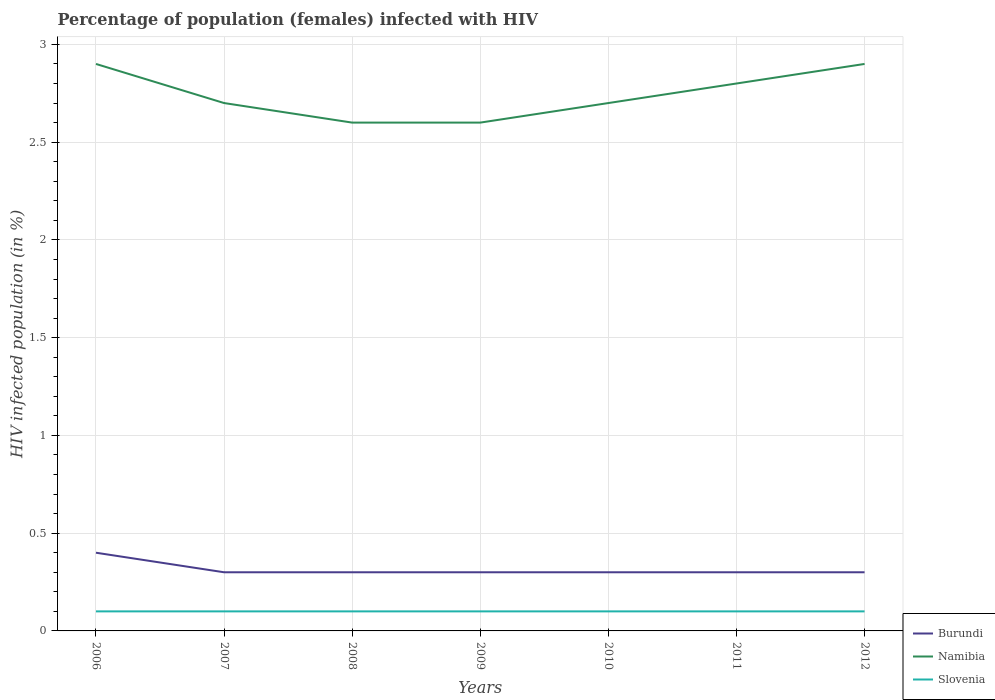Does the line corresponding to Namibia intersect with the line corresponding to Burundi?
Provide a short and direct response. No. Is the number of lines equal to the number of legend labels?
Offer a very short reply. Yes. Across all years, what is the maximum percentage of HIV infected female population in Slovenia?
Provide a short and direct response. 0.1. In which year was the percentage of HIV infected female population in Burundi maximum?
Your response must be concise. 2007. What is the total percentage of HIV infected female population in Burundi in the graph?
Your answer should be compact. 0.1. What is the difference between the highest and the second highest percentage of HIV infected female population in Burundi?
Ensure brevity in your answer.  0.1. How many lines are there?
Your answer should be compact. 3. How many years are there in the graph?
Provide a succinct answer. 7. What is the difference between two consecutive major ticks on the Y-axis?
Your answer should be compact. 0.5. Are the values on the major ticks of Y-axis written in scientific E-notation?
Keep it short and to the point. No. Where does the legend appear in the graph?
Your answer should be compact. Bottom right. How many legend labels are there?
Give a very brief answer. 3. What is the title of the graph?
Keep it short and to the point. Percentage of population (females) infected with HIV. What is the label or title of the X-axis?
Make the answer very short. Years. What is the label or title of the Y-axis?
Ensure brevity in your answer.  HIV infected population (in %). What is the HIV infected population (in %) of Namibia in 2007?
Ensure brevity in your answer.  2.7. What is the HIV infected population (in %) in Burundi in 2009?
Provide a short and direct response. 0.3. What is the HIV infected population (in %) in Namibia in 2009?
Your answer should be very brief. 2.6. What is the HIV infected population (in %) in Namibia in 2011?
Offer a terse response. 2.8. What is the HIV infected population (in %) in Burundi in 2012?
Your answer should be compact. 0.3. Across all years, what is the minimum HIV infected population (in %) in Burundi?
Your response must be concise. 0.3. Across all years, what is the minimum HIV infected population (in %) in Namibia?
Provide a short and direct response. 2.6. Across all years, what is the minimum HIV infected population (in %) in Slovenia?
Your answer should be very brief. 0.1. What is the total HIV infected population (in %) in Burundi in the graph?
Offer a terse response. 2.2. What is the total HIV infected population (in %) of Namibia in the graph?
Make the answer very short. 19.2. What is the difference between the HIV infected population (in %) in Namibia in 2006 and that in 2007?
Provide a succinct answer. 0.2. What is the difference between the HIV infected population (in %) of Slovenia in 2006 and that in 2007?
Keep it short and to the point. 0. What is the difference between the HIV infected population (in %) of Burundi in 2006 and that in 2008?
Keep it short and to the point. 0.1. What is the difference between the HIV infected population (in %) of Slovenia in 2006 and that in 2008?
Your response must be concise. 0. What is the difference between the HIV infected population (in %) in Burundi in 2006 and that in 2009?
Keep it short and to the point. 0.1. What is the difference between the HIV infected population (in %) of Burundi in 2006 and that in 2010?
Keep it short and to the point. 0.1. What is the difference between the HIV infected population (in %) of Slovenia in 2006 and that in 2010?
Give a very brief answer. 0. What is the difference between the HIV infected population (in %) of Namibia in 2006 and that in 2011?
Offer a terse response. 0.1. What is the difference between the HIV infected population (in %) in Namibia in 2006 and that in 2012?
Your response must be concise. 0. What is the difference between the HIV infected population (in %) of Namibia in 2007 and that in 2009?
Offer a terse response. 0.1. What is the difference between the HIV infected population (in %) of Namibia in 2007 and that in 2010?
Provide a succinct answer. 0. What is the difference between the HIV infected population (in %) of Slovenia in 2007 and that in 2010?
Your answer should be very brief. 0. What is the difference between the HIV infected population (in %) in Namibia in 2007 and that in 2011?
Your answer should be very brief. -0.1. What is the difference between the HIV infected population (in %) of Slovenia in 2007 and that in 2011?
Provide a succinct answer. 0. What is the difference between the HIV infected population (in %) in Burundi in 2007 and that in 2012?
Keep it short and to the point. 0. What is the difference between the HIV infected population (in %) of Namibia in 2007 and that in 2012?
Your answer should be compact. -0.2. What is the difference between the HIV infected population (in %) in Burundi in 2008 and that in 2009?
Your answer should be compact. 0. What is the difference between the HIV infected population (in %) of Slovenia in 2008 and that in 2009?
Provide a succinct answer. 0. What is the difference between the HIV infected population (in %) in Burundi in 2008 and that in 2010?
Provide a short and direct response. 0. What is the difference between the HIV infected population (in %) of Burundi in 2008 and that in 2011?
Keep it short and to the point. 0. What is the difference between the HIV infected population (in %) of Namibia in 2008 and that in 2011?
Offer a very short reply. -0.2. What is the difference between the HIV infected population (in %) of Slovenia in 2008 and that in 2012?
Offer a very short reply. 0. What is the difference between the HIV infected population (in %) in Burundi in 2009 and that in 2010?
Ensure brevity in your answer.  0. What is the difference between the HIV infected population (in %) of Slovenia in 2009 and that in 2010?
Your answer should be compact. 0. What is the difference between the HIV infected population (in %) of Burundi in 2009 and that in 2011?
Your answer should be very brief. 0. What is the difference between the HIV infected population (in %) in Namibia in 2009 and that in 2011?
Offer a terse response. -0.2. What is the difference between the HIV infected population (in %) in Burundi in 2010 and that in 2011?
Your answer should be compact. 0. What is the difference between the HIV infected population (in %) in Namibia in 2010 and that in 2011?
Your answer should be compact. -0.1. What is the difference between the HIV infected population (in %) in Slovenia in 2010 and that in 2011?
Ensure brevity in your answer.  0. What is the difference between the HIV infected population (in %) of Burundi in 2010 and that in 2012?
Provide a short and direct response. 0. What is the difference between the HIV infected population (in %) in Burundi in 2011 and that in 2012?
Your response must be concise. 0. What is the difference between the HIV infected population (in %) in Namibia in 2011 and that in 2012?
Your answer should be very brief. -0.1. What is the difference between the HIV infected population (in %) of Slovenia in 2011 and that in 2012?
Your answer should be compact. 0. What is the difference between the HIV infected population (in %) of Burundi in 2006 and the HIV infected population (in %) of Namibia in 2007?
Make the answer very short. -2.3. What is the difference between the HIV infected population (in %) of Burundi in 2006 and the HIV infected population (in %) of Slovenia in 2007?
Keep it short and to the point. 0.3. What is the difference between the HIV infected population (in %) in Burundi in 2006 and the HIV infected population (in %) in Namibia in 2008?
Provide a succinct answer. -2.2. What is the difference between the HIV infected population (in %) in Burundi in 2006 and the HIV infected population (in %) in Namibia in 2009?
Keep it short and to the point. -2.2. What is the difference between the HIV infected population (in %) in Burundi in 2006 and the HIV infected population (in %) in Slovenia in 2010?
Your response must be concise. 0.3. What is the difference between the HIV infected population (in %) of Namibia in 2006 and the HIV infected population (in %) of Slovenia in 2010?
Give a very brief answer. 2.8. What is the difference between the HIV infected population (in %) in Burundi in 2006 and the HIV infected population (in %) in Slovenia in 2012?
Offer a terse response. 0.3. What is the difference between the HIV infected population (in %) of Burundi in 2007 and the HIV infected population (in %) of Slovenia in 2008?
Give a very brief answer. 0.2. What is the difference between the HIV infected population (in %) in Namibia in 2007 and the HIV infected population (in %) in Slovenia in 2008?
Your response must be concise. 2.6. What is the difference between the HIV infected population (in %) of Burundi in 2007 and the HIV infected population (in %) of Namibia in 2009?
Provide a short and direct response. -2.3. What is the difference between the HIV infected population (in %) in Burundi in 2007 and the HIV infected population (in %) in Slovenia in 2009?
Provide a succinct answer. 0.2. What is the difference between the HIV infected population (in %) of Namibia in 2007 and the HIV infected population (in %) of Slovenia in 2009?
Give a very brief answer. 2.6. What is the difference between the HIV infected population (in %) in Namibia in 2007 and the HIV infected population (in %) in Slovenia in 2010?
Offer a very short reply. 2.6. What is the difference between the HIV infected population (in %) of Burundi in 2007 and the HIV infected population (in %) of Slovenia in 2011?
Your answer should be compact. 0.2. What is the difference between the HIV infected population (in %) of Namibia in 2007 and the HIV infected population (in %) of Slovenia in 2011?
Give a very brief answer. 2.6. What is the difference between the HIV infected population (in %) of Burundi in 2007 and the HIV infected population (in %) of Namibia in 2012?
Your answer should be very brief. -2.6. What is the difference between the HIV infected population (in %) of Namibia in 2007 and the HIV infected population (in %) of Slovenia in 2012?
Make the answer very short. 2.6. What is the difference between the HIV infected population (in %) in Burundi in 2008 and the HIV infected population (in %) in Slovenia in 2009?
Make the answer very short. 0.2. What is the difference between the HIV infected population (in %) in Namibia in 2008 and the HIV infected population (in %) in Slovenia in 2009?
Offer a terse response. 2.5. What is the difference between the HIV infected population (in %) of Burundi in 2008 and the HIV infected population (in %) of Slovenia in 2010?
Offer a terse response. 0.2. What is the difference between the HIV infected population (in %) in Burundi in 2008 and the HIV infected population (in %) in Slovenia in 2011?
Offer a very short reply. 0.2. What is the difference between the HIV infected population (in %) of Namibia in 2008 and the HIV infected population (in %) of Slovenia in 2011?
Ensure brevity in your answer.  2.5. What is the difference between the HIV infected population (in %) of Burundi in 2008 and the HIV infected population (in %) of Slovenia in 2012?
Offer a very short reply. 0.2. What is the difference between the HIV infected population (in %) in Namibia in 2008 and the HIV infected population (in %) in Slovenia in 2012?
Ensure brevity in your answer.  2.5. What is the difference between the HIV infected population (in %) in Burundi in 2009 and the HIV infected population (in %) in Namibia in 2010?
Make the answer very short. -2.4. What is the difference between the HIV infected population (in %) in Burundi in 2009 and the HIV infected population (in %) in Slovenia in 2010?
Your answer should be compact. 0.2. What is the difference between the HIV infected population (in %) of Burundi in 2009 and the HIV infected population (in %) of Slovenia in 2011?
Your response must be concise. 0.2. What is the difference between the HIV infected population (in %) in Namibia in 2009 and the HIV infected population (in %) in Slovenia in 2012?
Your answer should be very brief. 2.5. What is the difference between the HIV infected population (in %) of Burundi in 2010 and the HIV infected population (in %) of Slovenia in 2011?
Provide a succinct answer. 0.2. What is the difference between the HIV infected population (in %) of Namibia in 2010 and the HIV infected population (in %) of Slovenia in 2011?
Provide a succinct answer. 2.6. What is the difference between the HIV infected population (in %) of Burundi in 2010 and the HIV infected population (in %) of Namibia in 2012?
Offer a terse response. -2.6. What is the difference between the HIV infected population (in %) of Burundi in 2010 and the HIV infected population (in %) of Slovenia in 2012?
Your response must be concise. 0.2. What is the average HIV infected population (in %) in Burundi per year?
Provide a succinct answer. 0.31. What is the average HIV infected population (in %) in Namibia per year?
Offer a terse response. 2.74. What is the average HIV infected population (in %) of Slovenia per year?
Keep it short and to the point. 0.1. In the year 2006, what is the difference between the HIV infected population (in %) of Burundi and HIV infected population (in %) of Slovenia?
Your answer should be very brief. 0.3. In the year 2007, what is the difference between the HIV infected population (in %) of Namibia and HIV infected population (in %) of Slovenia?
Your answer should be very brief. 2.6. In the year 2009, what is the difference between the HIV infected population (in %) of Burundi and HIV infected population (in %) of Slovenia?
Your response must be concise. 0.2. In the year 2009, what is the difference between the HIV infected population (in %) in Namibia and HIV infected population (in %) in Slovenia?
Keep it short and to the point. 2.5. In the year 2010, what is the difference between the HIV infected population (in %) in Burundi and HIV infected population (in %) in Namibia?
Give a very brief answer. -2.4. In the year 2010, what is the difference between the HIV infected population (in %) of Namibia and HIV infected population (in %) of Slovenia?
Give a very brief answer. 2.6. In the year 2011, what is the difference between the HIV infected population (in %) in Burundi and HIV infected population (in %) in Namibia?
Make the answer very short. -2.5. In the year 2012, what is the difference between the HIV infected population (in %) of Burundi and HIV infected population (in %) of Namibia?
Offer a terse response. -2.6. In the year 2012, what is the difference between the HIV infected population (in %) in Burundi and HIV infected population (in %) in Slovenia?
Make the answer very short. 0.2. What is the ratio of the HIV infected population (in %) of Burundi in 2006 to that in 2007?
Offer a very short reply. 1.33. What is the ratio of the HIV infected population (in %) in Namibia in 2006 to that in 2007?
Your answer should be compact. 1.07. What is the ratio of the HIV infected population (in %) of Burundi in 2006 to that in 2008?
Your answer should be compact. 1.33. What is the ratio of the HIV infected population (in %) of Namibia in 2006 to that in 2008?
Offer a terse response. 1.12. What is the ratio of the HIV infected population (in %) of Namibia in 2006 to that in 2009?
Provide a short and direct response. 1.12. What is the ratio of the HIV infected population (in %) of Namibia in 2006 to that in 2010?
Ensure brevity in your answer.  1.07. What is the ratio of the HIV infected population (in %) of Namibia in 2006 to that in 2011?
Keep it short and to the point. 1.04. What is the ratio of the HIV infected population (in %) in Slovenia in 2006 to that in 2011?
Your answer should be very brief. 1. What is the ratio of the HIV infected population (in %) in Namibia in 2006 to that in 2012?
Offer a very short reply. 1. What is the ratio of the HIV infected population (in %) in Burundi in 2007 to that in 2009?
Your answer should be compact. 1. What is the ratio of the HIV infected population (in %) in Namibia in 2007 to that in 2009?
Provide a succinct answer. 1.04. What is the ratio of the HIV infected population (in %) of Burundi in 2007 to that in 2010?
Provide a succinct answer. 1. What is the ratio of the HIV infected population (in %) of Namibia in 2007 to that in 2010?
Your answer should be compact. 1. What is the ratio of the HIV infected population (in %) of Burundi in 2007 to that in 2012?
Your answer should be compact. 1. What is the ratio of the HIV infected population (in %) in Namibia in 2007 to that in 2012?
Offer a very short reply. 0.93. What is the ratio of the HIV infected population (in %) of Slovenia in 2007 to that in 2012?
Ensure brevity in your answer.  1. What is the ratio of the HIV infected population (in %) of Burundi in 2008 to that in 2010?
Your response must be concise. 1. What is the ratio of the HIV infected population (in %) in Slovenia in 2008 to that in 2010?
Provide a succinct answer. 1. What is the ratio of the HIV infected population (in %) of Burundi in 2008 to that in 2011?
Your answer should be compact. 1. What is the ratio of the HIV infected population (in %) of Namibia in 2008 to that in 2011?
Provide a short and direct response. 0.93. What is the ratio of the HIV infected population (in %) in Slovenia in 2008 to that in 2011?
Your answer should be very brief. 1. What is the ratio of the HIV infected population (in %) in Burundi in 2008 to that in 2012?
Give a very brief answer. 1. What is the ratio of the HIV infected population (in %) in Namibia in 2008 to that in 2012?
Keep it short and to the point. 0.9. What is the ratio of the HIV infected population (in %) in Slovenia in 2008 to that in 2012?
Give a very brief answer. 1. What is the ratio of the HIV infected population (in %) in Burundi in 2009 to that in 2011?
Provide a short and direct response. 1. What is the ratio of the HIV infected population (in %) in Slovenia in 2009 to that in 2011?
Provide a succinct answer. 1. What is the ratio of the HIV infected population (in %) in Burundi in 2009 to that in 2012?
Ensure brevity in your answer.  1. What is the ratio of the HIV infected population (in %) of Namibia in 2009 to that in 2012?
Provide a short and direct response. 0.9. What is the ratio of the HIV infected population (in %) in Burundi in 2010 to that in 2012?
Ensure brevity in your answer.  1. What is the ratio of the HIV infected population (in %) of Slovenia in 2010 to that in 2012?
Your response must be concise. 1. What is the ratio of the HIV infected population (in %) of Namibia in 2011 to that in 2012?
Your answer should be very brief. 0.97. What is the difference between the highest and the second highest HIV infected population (in %) of Namibia?
Provide a succinct answer. 0. What is the difference between the highest and the lowest HIV infected population (in %) in Slovenia?
Provide a short and direct response. 0. 